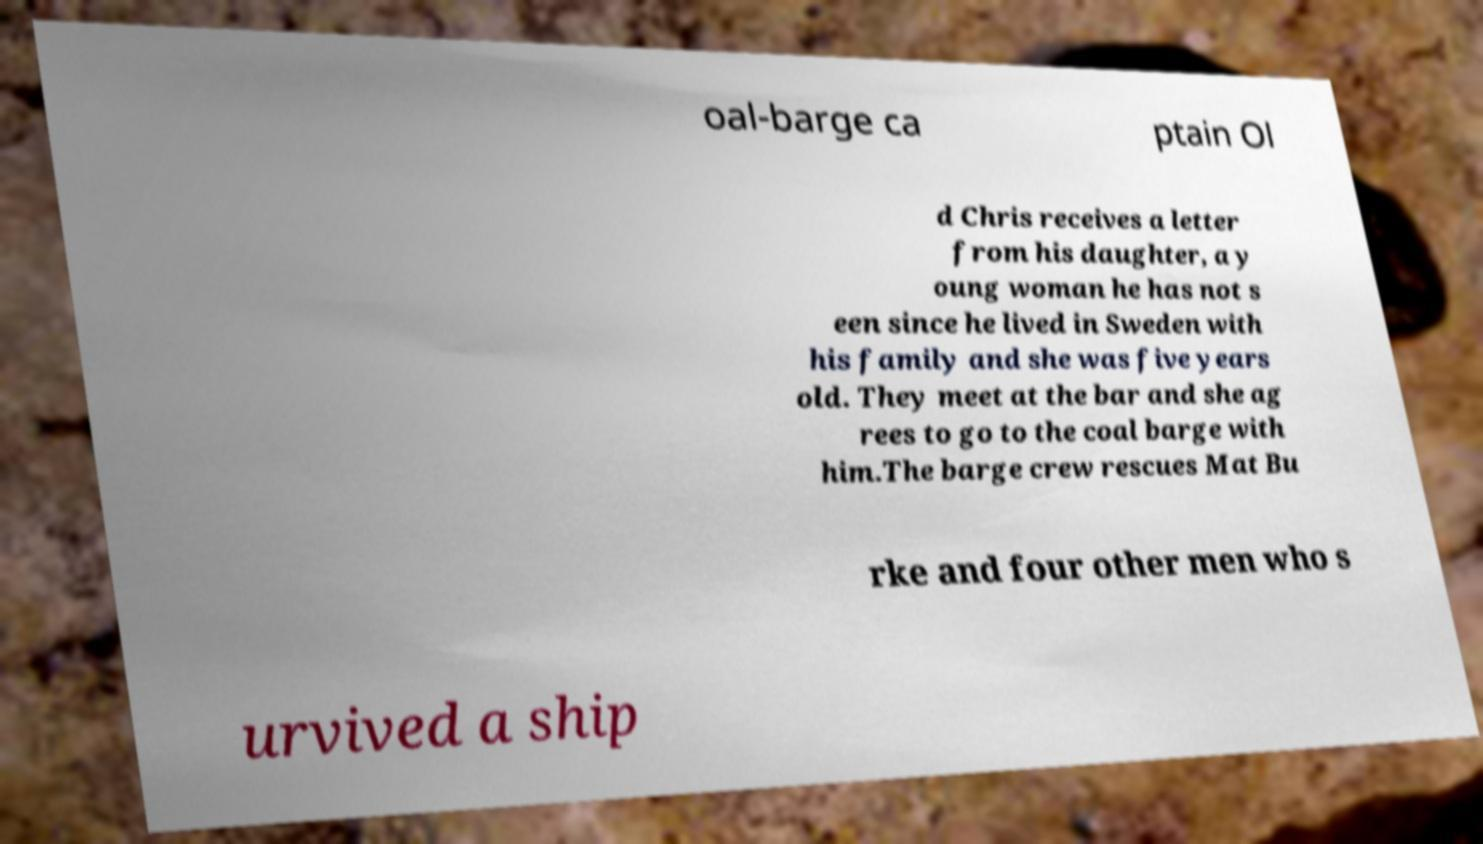Please identify and transcribe the text found in this image. oal-barge ca ptain Ol d Chris receives a letter from his daughter, a y oung woman he has not s een since he lived in Sweden with his family and she was five years old. They meet at the bar and she ag rees to go to the coal barge with him.The barge crew rescues Mat Bu rke and four other men who s urvived a ship 